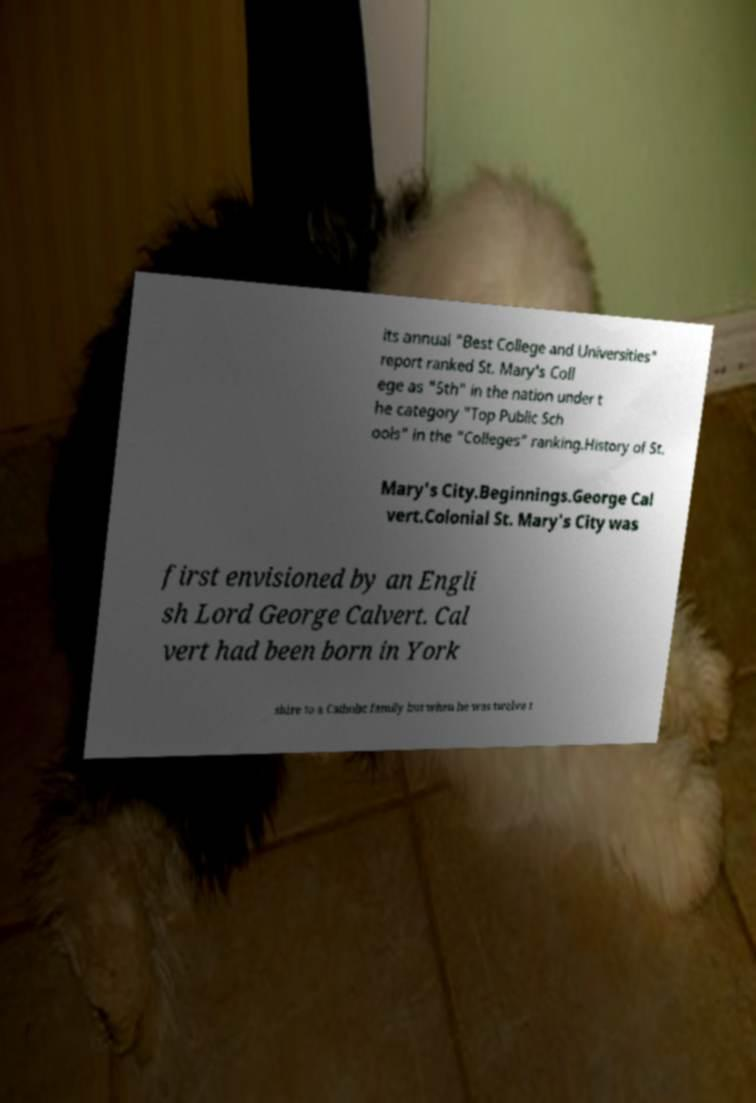Can you read and provide the text displayed in the image?This photo seems to have some interesting text. Can you extract and type it out for me? its annual "Best College and Universities" report ranked St. Mary's Coll ege as "5th" in the nation under t he category "Top Public Sch ools" in the "Colleges" ranking.History of St. Mary's City.Beginnings.George Cal vert.Colonial St. Mary's City was first envisioned by an Engli sh Lord George Calvert. Cal vert had been born in York shire to a Catholic family but when he was twelve t 